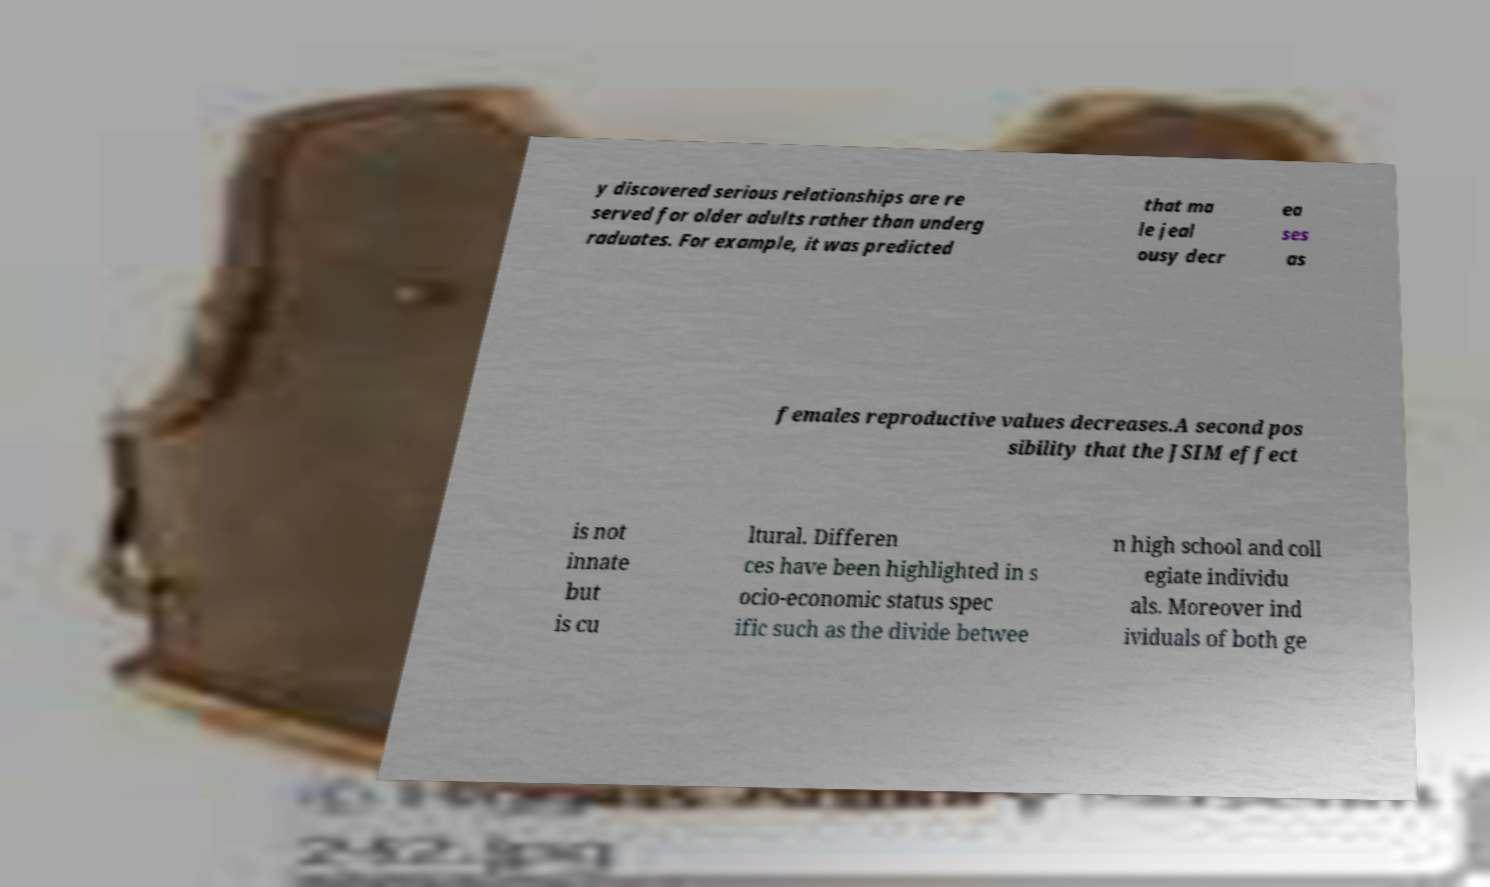I need the written content from this picture converted into text. Can you do that? y discovered serious relationships are re served for older adults rather than underg raduates. For example, it was predicted that ma le jeal ousy decr ea ses as females reproductive values decreases.A second pos sibility that the JSIM effect is not innate but is cu ltural. Differen ces have been highlighted in s ocio-economic status spec ific such as the divide betwee n high school and coll egiate individu als. Moreover ind ividuals of both ge 